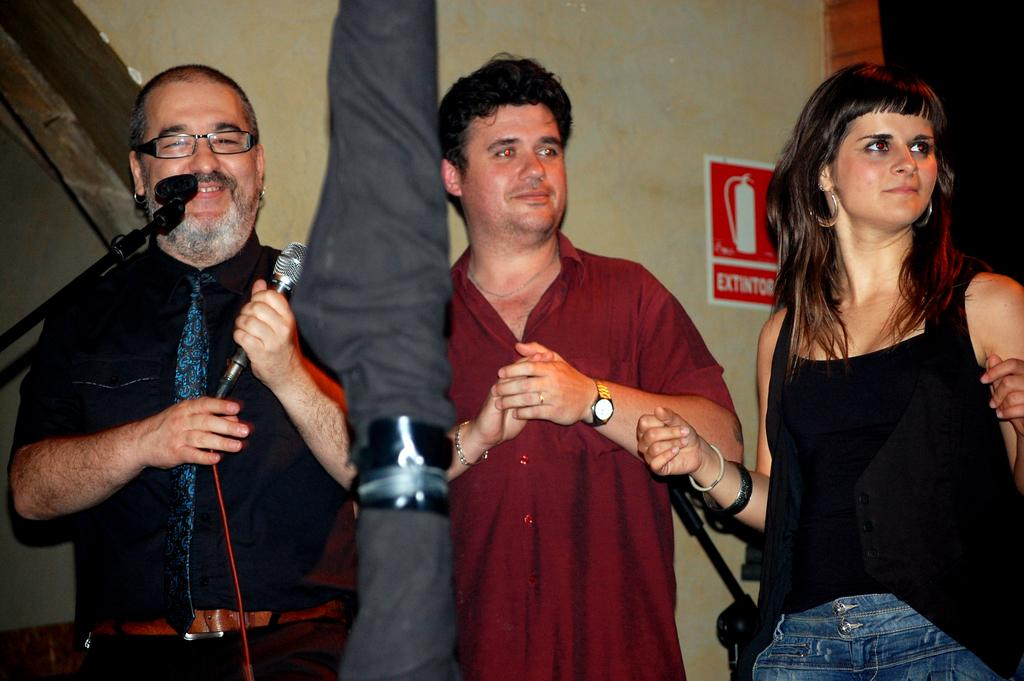What can be seen in the background of the image? There is a wall in the image. What is attached to the wall? There is a poster in the image. How many people are in the image? There are three people standing in the image. Where is the man standing in relation to the other people? The man is standing on the left side. What is the man holding? The man is holding a mic. What type of bottle is being used by the man to balance on his toes in the image? There is no bottle or toes-balancing activity present in the image. What is the man eating off of a plate in the image? There is no plate or eating activity present in the image. 